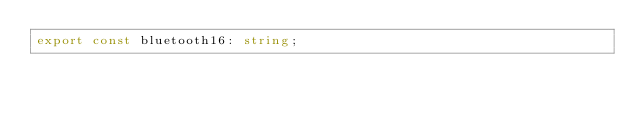<code> <loc_0><loc_0><loc_500><loc_500><_TypeScript_>export const bluetooth16: string;
</code> 